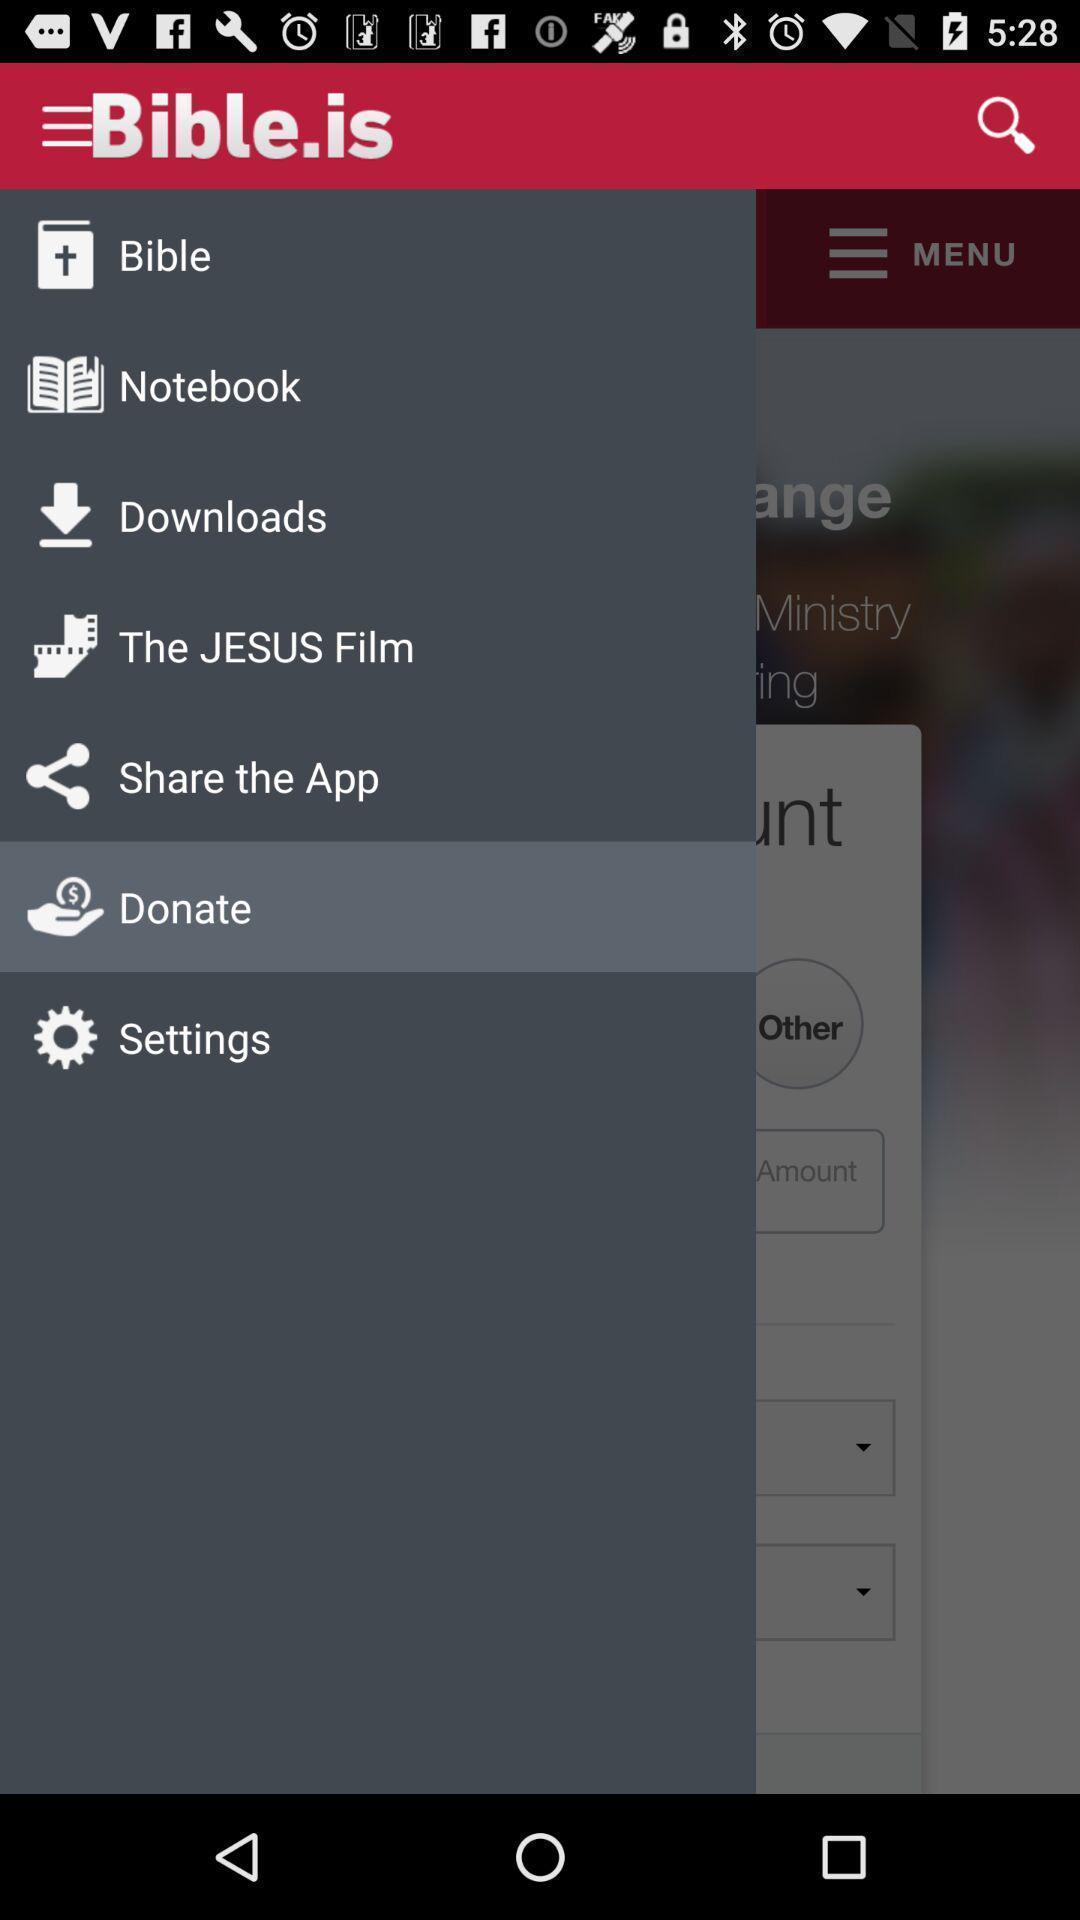Describe this image in words. Pop-up showing the multiple features. 